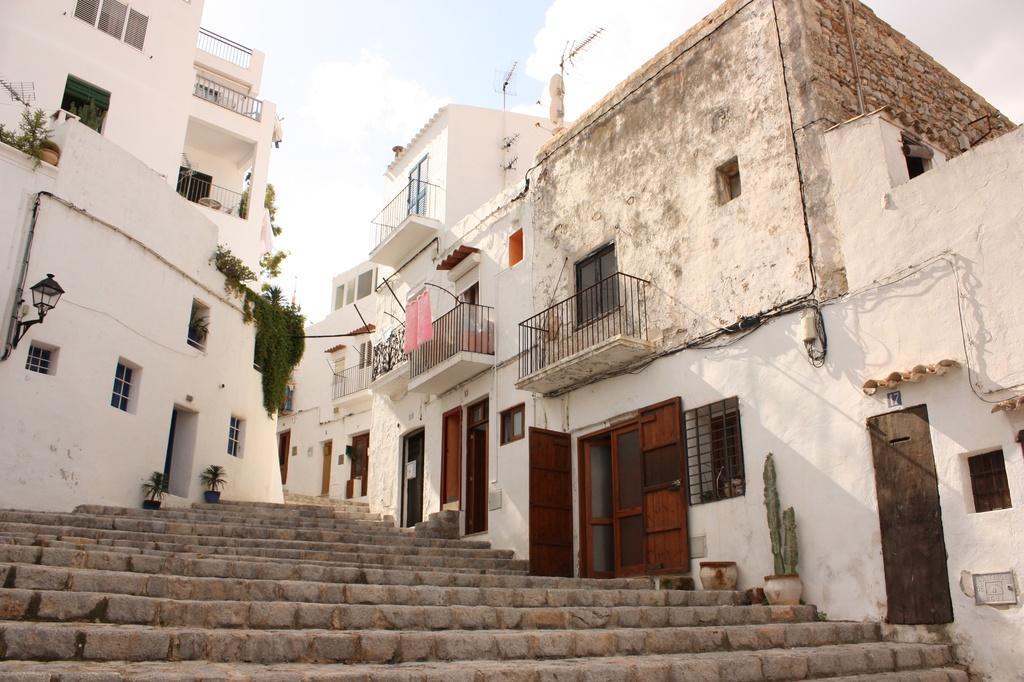Can you describe this image briefly? In this image I can see buildings. There are plants, flower pots, stairs, windows, doors and iron grilles. There is light and in the background there is sky. 